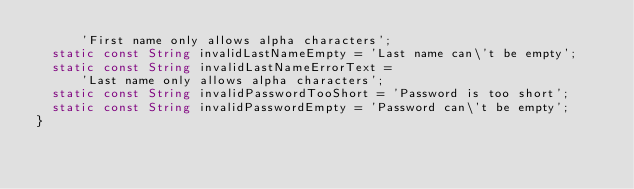<code> <loc_0><loc_0><loc_500><loc_500><_Dart_>      'First name only allows alpha characters';
  static const String invalidLastNameEmpty = 'Last name can\'t be empty';
  static const String invalidLastNameErrorText =
      'Last name only allows alpha characters';
  static const String invalidPasswordTooShort = 'Password is too short';
  static const String invalidPasswordEmpty = 'Password can\'t be empty';
}
</code> 